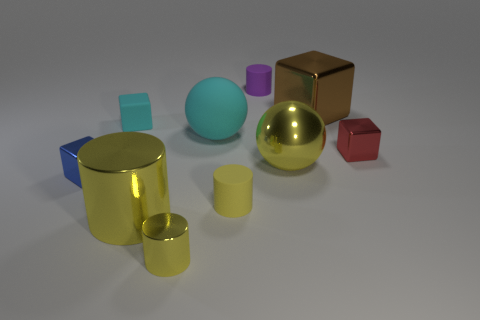Subtract all large yellow shiny cylinders. How many cylinders are left? 3 Subtract all green spheres. How many yellow cylinders are left? 3 Subtract all purple cylinders. How many cylinders are left? 3 Subtract 2 cubes. How many cubes are left? 2 Subtract all gray cubes. Subtract all yellow spheres. How many cubes are left? 4 Subtract all blocks. How many objects are left? 6 Subtract all small purple rubber cylinders. Subtract all big matte balls. How many objects are left? 8 Add 3 yellow matte cylinders. How many yellow matte cylinders are left? 4 Add 6 large metallic spheres. How many large metallic spheres exist? 7 Subtract 1 blue cubes. How many objects are left? 9 